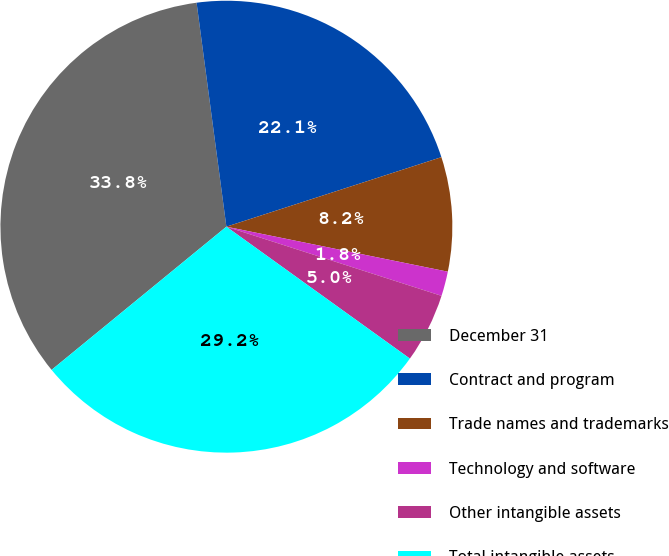Convert chart to OTSL. <chart><loc_0><loc_0><loc_500><loc_500><pie_chart><fcel>December 31<fcel>Contract and program<fcel>Trade names and trademarks<fcel>Technology and software<fcel>Other intangible assets<fcel>Total intangible assets<nl><fcel>33.82%<fcel>22.13%<fcel>8.17%<fcel>1.76%<fcel>4.97%<fcel>29.16%<nl></chart> 